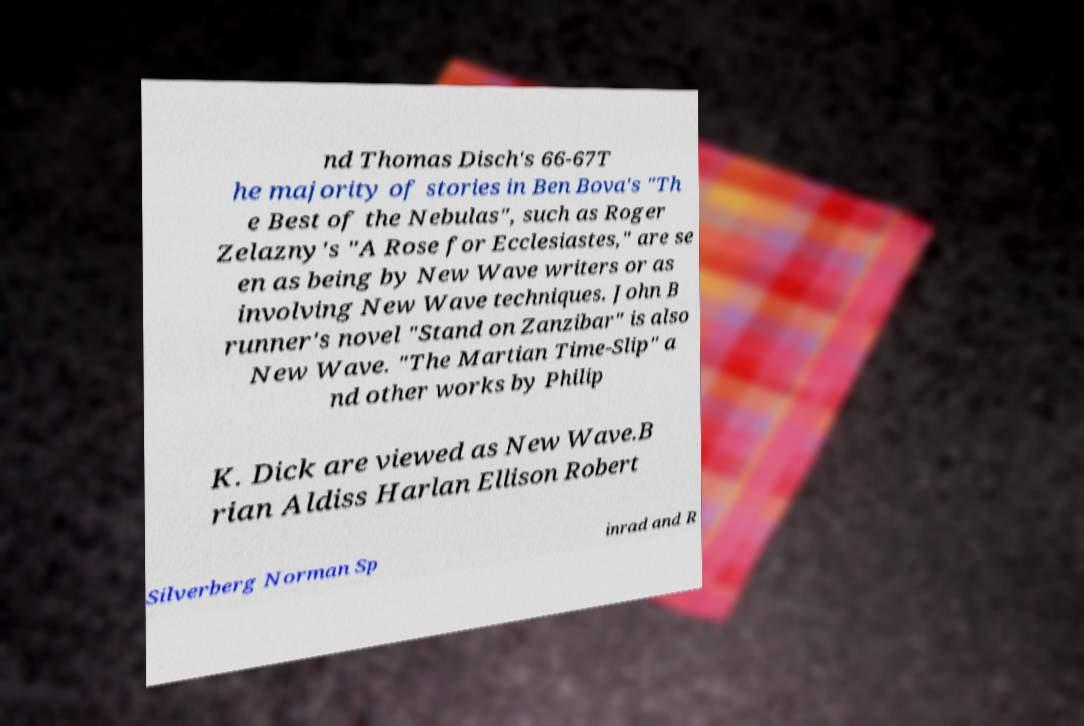Could you extract and type out the text from this image? nd Thomas Disch's 66-67T he majority of stories in Ben Bova's "Th e Best of the Nebulas", such as Roger Zelazny's "A Rose for Ecclesiastes," are se en as being by New Wave writers or as involving New Wave techniques. John B runner's novel "Stand on Zanzibar" is also New Wave. "The Martian Time-Slip" a nd other works by Philip K. Dick are viewed as New Wave.B rian Aldiss Harlan Ellison Robert Silverberg Norman Sp inrad and R 